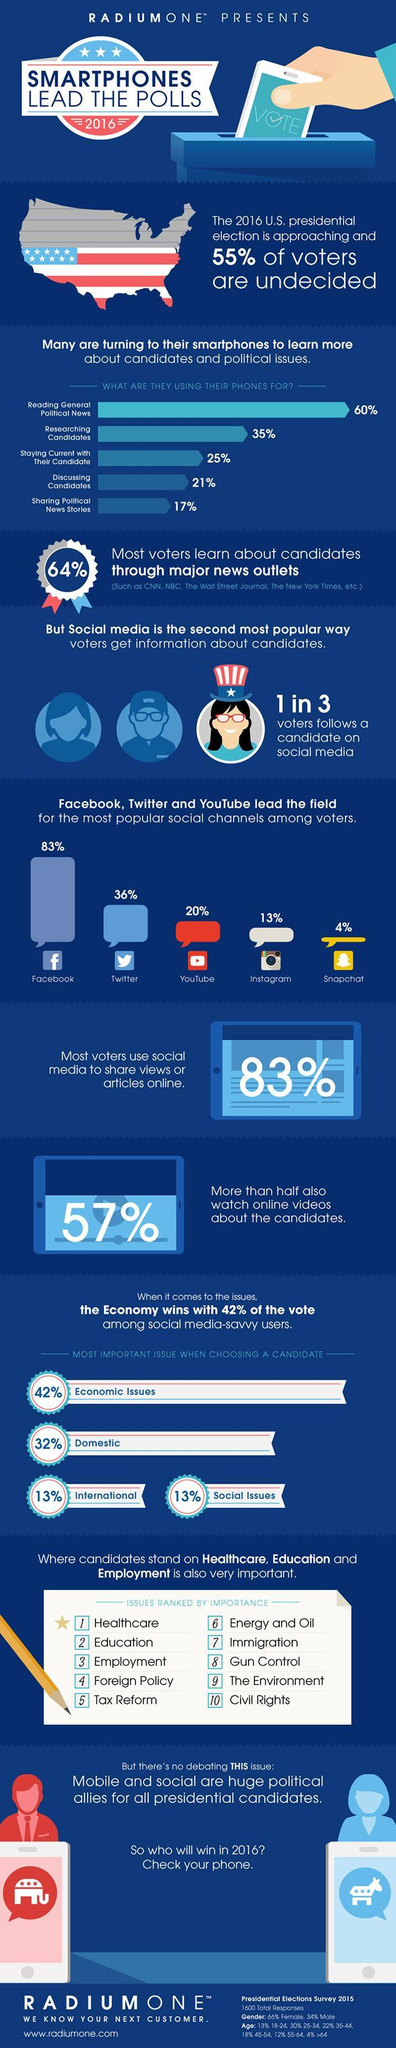What percentage of voters learn about candidates, not through major news outlets?
Answer the question with a short phrase. 36% What percentage are using their smartphones for reading general political news and sharing political news stories, taken together? 77% What percentage of voters didn't use social media to share views or articles online? 17% Out of 3, how many didn't follow a candidate on social media? 2 What percentage are using their smartphones for "researching candidates" and "discussing candidates" taken together? 56% 